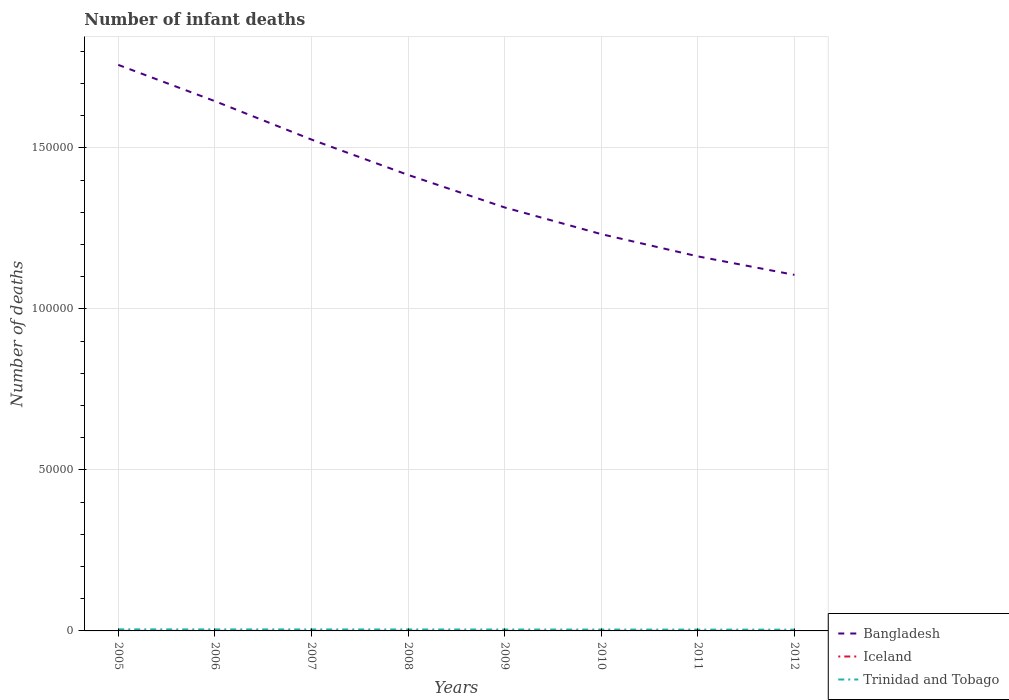Does the line corresponding to Iceland intersect with the line corresponding to Bangladesh?
Offer a very short reply. No. Across all years, what is the maximum number of infant deaths in Iceland?
Offer a terse response. 8. In which year was the number of infant deaths in Trinidad and Tobago maximum?
Ensure brevity in your answer.  2012. What is the total number of infant deaths in Iceland in the graph?
Your response must be concise. 1. What is the difference between the highest and the second highest number of infant deaths in Iceland?
Your response must be concise. 2. Is the number of infant deaths in Bangladesh strictly greater than the number of infant deaths in Iceland over the years?
Your response must be concise. No. How many lines are there?
Make the answer very short. 3. What is the difference between two consecutive major ticks on the Y-axis?
Give a very brief answer. 5.00e+04. Are the values on the major ticks of Y-axis written in scientific E-notation?
Keep it short and to the point. No. Does the graph contain any zero values?
Provide a short and direct response. No. Does the graph contain grids?
Ensure brevity in your answer.  Yes. How many legend labels are there?
Offer a very short reply. 3. What is the title of the graph?
Make the answer very short. Number of infant deaths. What is the label or title of the X-axis?
Your answer should be compact. Years. What is the label or title of the Y-axis?
Your response must be concise. Number of deaths. What is the Number of deaths of Bangladesh in 2005?
Your answer should be compact. 1.76e+05. What is the Number of deaths in Iceland in 2005?
Keep it short and to the point. 10. What is the Number of deaths in Trinidad and Tobago in 2005?
Offer a very short reply. 481. What is the Number of deaths in Bangladesh in 2006?
Your response must be concise. 1.65e+05. What is the Number of deaths in Trinidad and Tobago in 2006?
Offer a terse response. 475. What is the Number of deaths in Bangladesh in 2007?
Your answer should be compact. 1.53e+05. What is the Number of deaths in Trinidad and Tobago in 2007?
Provide a short and direct response. 466. What is the Number of deaths of Bangladesh in 2008?
Offer a very short reply. 1.42e+05. What is the Number of deaths in Iceland in 2008?
Provide a short and direct response. 10. What is the Number of deaths in Trinidad and Tobago in 2008?
Make the answer very short. 452. What is the Number of deaths of Bangladesh in 2009?
Make the answer very short. 1.32e+05. What is the Number of deaths of Trinidad and Tobago in 2009?
Your answer should be compact. 438. What is the Number of deaths in Bangladesh in 2010?
Offer a very short reply. 1.23e+05. What is the Number of deaths in Trinidad and Tobago in 2010?
Offer a terse response. 423. What is the Number of deaths in Bangladesh in 2011?
Your answer should be very brief. 1.16e+05. What is the Number of deaths in Iceland in 2011?
Your answer should be very brief. 9. What is the Number of deaths in Trinidad and Tobago in 2011?
Provide a succinct answer. 407. What is the Number of deaths of Bangladesh in 2012?
Offer a terse response. 1.11e+05. What is the Number of deaths in Trinidad and Tobago in 2012?
Provide a short and direct response. 389. Across all years, what is the maximum Number of deaths of Bangladesh?
Make the answer very short. 1.76e+05. Across all years, what is the maximum Number of deaths of Iceland?
Offer a very short reply. 10. Across all years, what is the maximum Number of deaths in Trinidad and Tobago?
Keep it short and to the point. 481. Across all years, what is the minimum Number of deaths of Bangladesh?
Make the answer very short. 1.11e+05. Across all years, what is the minimum Number of deaths of Iceland?
Give a very brief answer. 8. Across all years, what is the minimum Number of deaths of Trinidad and Tobago?
Keep it short and to the point. 389. What is the total Number of deaths of Bangladesh in the graph?
Offer a very short reply. 1.12e+06. What is the total Number of deaths in Trinidad and Tobago in the graph?
Provide a short and direct response. 3531. What is the difference between the Number of deaths in Bangladesh in 2005 and that in 2006?
Make the answer very short. 1.13e+04. What is the difference between the Number of deaths of Bangladesh in 2005 and that in 2007?
Offer a terse response. 2.32e+04. What is the difference between the Number of deaths of Bangladesh in 2005 and that in 2008?
Provide a succinct answer. 3.42e+04. What is the difference between the Number of deaths of Bangladesh in 2005 and that in 2009?
Provide a succinct answer. 4.43e+04. What is the difference between the Number of deaths in Iceland in 2005 and that in 2009?
Make the answer very short. 0. What is the difference between the Number of deaths of Trinidad and Tobago in 2005 and that in 2009?
Your answer should be compact. 43. What is the difference between the Number of deaths of Bangladesh in 2005 and that in 2010?
Offer a very short reply. 5.26e+04. What is the difference between the Number of deaths of Iceland in 2005 and that in 2010?
Make the answer very short. 0. What is the difference between the Number of deaths in Trinidad and Tobago in 2005 and that in 2010?
Ensure brevity in your answer.  58. What is the difference between the Number of deaths in Bangladesh in 2005 and that in 2011?
Ensure brevity in your answer.  5.95e+04. What is the difference between the Number of deaths in Iceland in 2005 and that in 2011?
Make the answer very short. 1. What is the difference between the Number of deaths of Trinidad and Tobago in 2005 and that in 2011?
Give a very brief answer. 74. What is the difference between the Number of deaths in Bangladesh in 2005 and that in 2012?
Ensure brevity in your answer.  6.52e+04. What is the difference between the Number of deaths in Trinidad and Tobago in 2005 and that in 2012?
Make the answer very short. 92. What is the difference between the Number of deaths of Bangladesh in 2006 and that in 2007?
Offer a terse response. 1.19e+04. What is the difference between the Number of deaths in Bangladesh in 2006 and that in 2008?
Give a very brief answer. 2.29e+04. What is the difference between the Number of deaths in Iceland in 2006 and that in 2008?
Offer a terse response. 0. What is the difference between the Number of deaths in Bangladesh in 2006 and that in 2009?
Provide a short and direct response. 3.30e+04. What is the difference between the Number of deaths in Trinidad and Tobago in 2006 and that in 2009?
Your answer should be compact. 37. What is the difference between the Number of deaths in Bangladesh in 2006 and that in 2010?
Provide a succinct answer. 4.13e+04. What is the difference between the Number of deaths of Bangladesh in 2006 and that in 2011?
Offer a terse response. 4.82e+04. What is the difference between the Number of deaths in Trinidad and Tobago in 2006 and that in 2011?
Your answer should be compact. 68. What is the difference between the Number of deaths in Bangladesh in 2006 and that in 2012?
Make the answer very short. 5.40e+04. What is the difference between the Number of deaths of Trinidad and Tobago in 2006 and that in 2012?
Provide a short and direct response. 86. What is the difference between the Number of deaths in Bangladesh in 2007 and that in 2008?
Your answer should be very brief. 1.10e+04. What is the difference between the Number of deaths of Iceland in 2007 and that in 2008?
Your response must be concise. 0. What is the difference between the Number of deaths of Trinidad and Tobago in 2007 and that in 2008?
Your response must be concise. 14. What is the difference between the Number of deaths in Bangladesh in 2007 and that in 2009?
Offer a very short reply. 2.11e+04. What is the difference between the Number of deaths in Bangladesh in 2007 and that in 2010?
Ensure brevity in your answer.  2.94e+04. What is the difference between the Number of deaths of Iceland in 2007 and that in 2010?
Give a very brief answer. 0. What is the difference between the Number of deaths in Trinidad and Tobago in 2007 and that in 2010?
Keep it short and to the point. 43. What is the difference between the Number of deaths in Bangladesh in 2007 and that in 2011?
Give a very brief answer. 3.63e+04. What is the difference between the Number of deaths in Bangladesh in 2007 and that in 2012?
Provide a succinct answer. 4.20e+04. What is the difference between the Number of deaths in Iceland in 2007 and that in 2012?
Your answer should be compact. 2. What is the difference between the Number of deaths in Bangladesh in 2008 and that in 2009?
Keep it short and to the point. 1.01e+04. What is the difference between the Number of deaths in Iceland in 2008 and that in 2009?
Provide a succinct answer. 0. What is the difference between the Number of deaths in Bangladesh in 2008 and that in 2010?
Offer a terse response. 1.84e+04. What is the difference between the Number of deaths of Bangladesh in 2008 and that in 2011?
Offer a terse response. 2.53e+04. What is the difference between the Number of deaths of Iceland in 2008 and that in 2011?
Offer a very short reply. 1. What is the difference between the Number of deaths in Bangladesh in 2008 and that in 2012?
Keep it short and to the point. 3.10e+04. What is the difference between the Number of deaths in Bangladesh in 2009 and that in 2010?
Offer a very short reply. 8288. What is the difference between the Number of deaths in Bangladesh in 2009 and that in 2011?
Offer a terse response. 1.52e+04. What is the difference between the Number of deaths of Bangladesh in 2009 and that in 2012?
Your answer should be very brief. 2.09e+04. What is the difference between the Number of deaths in Trinidad and Tobago in 2009 and that in 2012?
Keep it short and to the point. 49. What is the difference between the Number of deaths of Bangladesh in 2010 and that in 2011?
Make the answer very short. 6909. What is the difference between the Number of deaths in Iceland in 2010 and that in 2011?
Your answer should be compact. 1. What is the difference between the Number of deaths in Trinidad and Tobago in 2010 and that in 2011?
Provide a succinct answer. 16. What is the difference between the Number of deaths of Bangladesh in 2010 and that in 2012?
Your answer should be very brief. 1.27e+04. What is the difference between the Number of deaths of Bangladesh in 2011 and that in 2012?
Keep it short and to the point. 5744. What is the difference between the Number of deaths in Iceland in 2011 and that in 2012?
Your answer should be compact. 1. What is the difference between the Number of deaths of Bangladesh in 2005 and the Number of deaths of Iceland in 2006?
Your response must be concise. 1.76e+05. What is the difference between the Number of deaths in Bangladesh in 2005 and the Number of deaths in Trinidad and Tobago in 2006?
Make the answer very short. 1.75e+05. What is the difference between the Number of deaths of Iceland in 2005 and the Number of deaths of Trinidad and Tobago in 2006?
Make the answer very short. -465. What is the difference between the Number of deaths in Bangladesh in 2005 and the Number of deaths in Iceland in 2007?
Make the answer very short. 1.76e+05. What is the difference between the Number of deaths of Bangladesh in 2005 and the Number of deaths of Trinidad and Tobago in 2007?
Provide a short and direct response. 1.75e+05. What is the difference between the Number of deaths of Iceland in 2005 and the Number of deaths of Trinidad and Tobago in 2007?
Your response must be concise. -456. What is the difference between the Number of deaths of Bangladesh in 2005 and the Number of deaths of Iceland in 2008?
Your answer should be compact. 1.76e+05. What is the difference between the Number of deaths in Bangladesh in 2005 and the Number of deaths in Trinidad and Tobago in 2008?
Your answer should be very brief. 1.75e+05. What is the difference between the Number of deaths of Iceland in 2005 and the Number of deaths of Trinidad and Tobago in 2008?
Offer a very short reply. -442. What is the difference between the Number of deaths of Bangladesh in 2005 and the Number of deaths of Iceland in 2009?
Make the answer very short. 1.76e+05. What is the difference between the Number of deaths of Bangladesh in 2005 and the Number of deaths of Trinidad and Tobago in 2009?
Your answer should be compact. 1.75e+05. What is the difference between the Number of deaths in Iceland in 2005 and the Number of deaths in Trinidad and Tobago in 2009?
Your answer should be compact. -428. What is the difference between the Number of deaths in Bangladesh in 2005 and the Number of deaths in Iceland in 2010?
Make the answer very short. 1.76e+05. What is the difference between the Number of deaths of Bangladesh in 2005 and the Number of deaths of Trinidad and Tobago in 2010?
Give a very brief answer. 1.75e+05. What is the difference between the Number of deaths in Iceland in 2005 and the Number of deaths in Trinidad and Tobago in 2010?
Provide a short and direct response. -413. What is the difference between the Number of deaths of Bangladesh in 2005 and the Number of deaths of Iceland in 2011?
Your answer should be very brief. 1.76e+05. What is the difference between the Number of deaths in Bangladesh in 2005 and the Number of deaths in Trinidad and Tobago in 2011?
Make the answer very short. 1.75e+05. What is the difference between the Number of deaths of Iceland in 2005 and the Number of deaths of Trinidad and Tobago in 2011?
Keep it short and to the point. -397. What is the difference between the Number of deaths in Bangladesh in 2005 and the Number of deaths in Iceland in 2012?
Your answer should be compact. 1.76e+05. What is the difference between the Number of deaths of Bangladesh in 2005 and the Number of deaths of Trinidad and Tobago in 2012?
Offer a very short reply. 1.75e+05. What is the difference between the Number of deaths of Iceland in 2005 and the Number of deaths of Trinidad and Tobago in 2012?
Give a very brief answer. -379. What is the difference between the Number of deaths in Bangladesh in 2006 and the Number of deaths in Iceland in 2007?
Offer a terse response. 1.65e+05. What is the difference between the Number of deaths in Bangladesh in 2006 and the Number of deaths in Trinidad and Tobago in 2007?
Your answer should be compact. 1.64e+05. What is the difference between the Number of deaths in Iceland in 2006 and the Number of deaths in Trinidad and Tobago in 2007?
Keep it short and to the point. -456. What is the difference between the Number of deaths of Bangladesh in 2006 and the Number of deaths of Iceland in 2008?
Offer a very short reply. 1.65e+05. What is the difference between the Number of deaths in Bangladesh in 2006 and the Number of deaths in Trinidad and Tobago in 2008?
Your answer should be very brief. 1.64e+05. What is the difference between the Number of deaths in Iceland in 2006 and the Number of deaths in Trinidad and Tobago in 2008?
Provide a short and direct response. -442. What is the difference between the Number of deaths in Bangladesh in 2006 and the Number of deaths in Iceland in 2009?
Provide a short and direct response. 1.65e+05. What is the difference between the Number of deaths in Bangladesh in 2006 and the Number of deaths in Trinidad and Tobago in 2009?
Keep it short and to the point. 1.64e+05. What is the difference between the Number of deaths in Iceland in 2006 and the Number of deaths in Trinidad and Tobago in 2009?
Give a very brief answer. -428. What is the difference between the Number of deaths of Bangladesh in 2006 and the Number of deaths of Iceland in 2010?
Give a very brief answer. 1.65e+05. What is the difference between the Number of deaths in Bangladesh in 2006 and the Number of deaths in Trinidad and Tobago in 2010?
Your response must be concise. 1.64e+05. What is the difference between the Number of deaths in Iceland in 2006 and the Number of deaths in Trinidad and Tobago in 2010?
Offer a terse response. -413. What is the difference between the Number of deaths of Bangladesh in 2006 and the Number of deaths of Iceland in 2011?
Provide a short and direct response. 1.65e+05. What is the difference between the Number of deaths of Bangladesh in 2006 and the Number of deaths of Trinidad and Tobago in 2011?
Your response must be concise. 1.64e+05. What is the difference between the Number of deaths in Iceland in 2006 and the Number of deaths in Trinidad and Tobago in 2011?
Ensure brevity in your answer.  -397. What is the difference between the Number of deaths in Bangladesh in 2006 and the Number of deaths in Iceland in 2012?
Your response must be concise. 1.65e+05. What is the difference between the Number of deaths of Bangladesh in 2006 and the Number of deaths of Trinidad and Tobago in 2012?
Give a very brief answer. 1.64e+05. What is the difference between the Number of deaths in Iceland in 2006 and the Number of deaths in Trinidad and Tobago in 2012?
Give a very brief answer. -379. What is the difference between the Number of deaths in Bangladesh in 2007 and the Number of deaths in Iceland in 2008?
Ensure brevity in your answer.  1.53e+05. What is the difference between the Number of deaths in Bangladesh in 2007 and the Number of deaths in Trinidad and Tobago in 2008?
Give a very brief answer. 1.52e+05. What is the difference between the Number of deaths of Iceland in 2007 and the Number of deaths of Trinidad and Tobago in 2008?
Provide a short and direct response. -442. What is the difference between the Number of deaths in Bangladesh in 2007 and the Number of deaths in Iceland in 2009?
Give a very brief answer. 1.53e+05. What is the difference between the Number of deaths in Bangladesh in 2007 and the Number of deaths in Trinidad and Tobago in 2009?
Offer a very short reply. 1.52e+05. What is the difference between the Number of deaths in Iceland in 2007 and the Number of deaths in Trinidad and Tobago in 2009?
Offer a terse response. -428. What is the difference between the Number of deaths in Bangladesh in 2007 and the Number of deaths in Iceland in 2010?
Keep it short and to the point. 1.53e+05. What is the difference between the Number of deaths in Bangladesh in 2007 and the Number of deaths in Trinidad and Tobago in 2010?
Your answer should be compact. 1.52e+05. What is the difference between the Number of deaths of Iceland in 2007 and the Number of deaths of Trinidad and Tobago in 2010?
Offer a terse response. -413. What is the difference between the Number of deaths of Bangladesh in 2007 and the Number of deaths of Iceland in 2011?
Provide a succinct answer. 1.53e+05. What is the difference between the Number of deaths in Bangladesh in 2007 and the Number of deaths in Trinidad and Tobago in 2011?
Provide a short and direct response. 1.52e+05. What is the difference between the Number of deaths in Iceland in 2007 and the Number of deaths in Trinidad and Tobago in 2011?
Ensure brevity in your answer.  -397. What is the difference between the Number of deaths of Bangladesh in 2007 and the Number of deaths of Iceland in 2012?
Give a very brief answer. 1.53e+05. What is the difference between the Number of deaths of Bangladesh in 2007 and the Number of deaths of Trinidad and Tobago in 2012?
Offer a terse response. 1.52e+05. What is the difference between the Number of deaths of Iceland in 2007 and the Number of deaths of Trinidad and Tobago in 2012?
Provide a succinct answer. -379. What is the difference between the Number of deaths in Bangladesh in 2008 and the Number of deaths in Iceland in 2009?
Provide a succinct answer. 1.42e+05. What is the difference between the Number of deaths of Bangladesh in 2008 and the Number of deaths of Trinidad and Tobago in 2009?
Your answer should be compact. 1.41e+05. What is the difference between the Number of deaths of Iceland in 2008 and the Number of deaths of Trinidad and Tobago in 2009?
Provide a succinct answer. -428. What is the difference between the Number of deaths of Bangladesh in 2008 and the Number of deaths of Iceland in 2010?
Your response must be concise. 1.42e+05. What is the difference between the Number of deaths of Bangladesh in 2008 and the Number of deaths of Trinidad and Tobago in 2010?
Offer a very short reply. 1.41e+05. What is the difference between the Number of deaths in Iceland in 2008 and the Number of deaths in Trinidad and Tobago in 2010?
Provide a short and direct response. -413. What is the difference between the Number of deaths of Bangladesh in 2008 and the Number of deaths of Iceland in 2011?
Provide a succinct answer. 1.42e+05. What is the difference between the Number of deaths of Bangladesh in 2008 and the Number of deaths of Trinidad and Tobago in 2011?
Offer a terse response. 1.41e+05. What is the difference between the Number of deaths in Iceland in 2008 and the Number of deaths in Trinidad and Tobago in 2011?
Give a very brief answer. -397. What is the difference between the Number of deaths of Bangladesh in 2008 and the Number of deaths of Iceland in 2012?
Offer a terse response. 1.42e+05. What is the difference between the Number of deaths in Bangladesh in 2008 and the Number of deaths in Trinidad and Tobago in 2012?
Provide a succinct answer. 1.41e+05. What is the difference between the Number of deaths in Iceland in 2008 and the Number of deaths in Trinidad and Tobago in 2012?
Ensure brevity in your answer.  -379. What is the difference between the Number of deaths of Bangladesh in 2009 and the Number of deaths of Iceland in 2010?
Offer a very short reply. 1.32e+05. What is the difference between the Number of deaths in Bangladesh in 2009 and the Number of deaths in Trinidad and Tobago in 2010?
Keep it short and to the point. 1.31e+05. What is the difference between the Number of deaths of Iceland in 2009 and the Number of deaths of Trinidad and Tobago in 2010?
Keep it short and to the point. -413. What is the difference between the Number of deaths in Bangladesh in 2009 and the Number of deaths in Iceland in 2011?
Your answer should be compact. 1.32e+05. What is the difference between the Number of deaths of Bangladesh in 2009 and the Number of deaths of Trinidad and Tobago in 2011?
Ensure brevity in your answer.  1.31e+05. What is the difference between the Number of deaths of Iceland in 2009 and the Number of deaths of Trinidad and Tobago in 2011?
Offer a terse response. -397. What is the difference between the Number of deaths in Bangladesh in 2009 and the Number of deaths in Iceland in 2012?
Provide a short and direct response. 1.32e+05. What is the difference between the Number of deaths in Bangladesh in 2009 and the Number of deaths in Trinidad and Tobago in 2012?
Your answer should be very brief. 1.31e+05. What is the difference between the Number of deaths of Iceland in 2009 and the Number of deaths of Trinidad and Tobago in 2012?
Give a very brief answer. -379. What is the difference between the Number of deaths in Bangladesh in 2010 and the Number of deaths in Iceland in 2011?
Your answer should be compact. 1.23e+05. What is the difference between the Number of deaths in Bangladesh in 2010 and the Number of deaths in Trinidad and Tobago in 2011?
Keep it short and to the point. 1.23e+05. What is the difference between the Number of deaths of Iceland in 2010 and the Number of deaths of Trinidad and Tobago in 2011?
Your response must be concise. -397. What is the difference between the Number of deaths of Bangladesh in 2010 and the Number of deaths of Iceland in 2012?
Offer a very short reply. 1.23e+05. What is the difference between the Number of deaths of Bangladesh in 2010 and the Number of deaths of Trinidad and Tobago in 2012?
Provide a succinct answer. 1.23e+05. What is the difference between the Number of deaths in Iceland in 2010 and the Number of deaths in Trinidad and Tobago in 2012?
Offer a very short reply. -379. What is the difference between the Number of deaths in Bangladesh in 2011 and the Number of deaths in Iceland in 2012?
Offer a very short reply. 1.16e+05. What is the difference between the Number of deaths of Bangladesh in 2011 and the Number of deaths of Trinidad and Tobago in 2012?
Your response must be concise. 1.16e+05. What is the difference between the Number of deaths of Iceland in 2011 and the Number of deaths of Trinidad and Tobago in 2012?
Your response must be concise. -380. What is the average Number of deaths of Bangladesh per year?
Make the answer very short. 1.40e+05. What is the average Number of deaths in Iceland per year?
Your response must be concise. 9.62. What is the average Number of deaths in Trinidad and Tobago per year?
Provide a succinct answer. 441.38. In the year 2005, what is the difference between the Number of deaths in Bangladesh and Number of deaths in Iceland?
Offer a terse response. 1.76e+05. In the year 2005, what is the difference between the Number of deaths of Bangladesh and Number of deaths of Trinidad and Tobago?
Offer a terse response. 1.75e+05. In the year 2005, what is the difference between the Number of deaths in Iceland and Number of deaths in Trinidad and Tobago?
Your answer should be compact. -471. In the year 2006, what is the difference between the Number of deaths of Bangladesh and Number of deaths of Iceland?
Provide a short and direct response. 1.65e+05. In the year 2006, what is the difference between the Number of deaths in Bangladesh and Number of deaths in Trinidad and Tobago?
Ensure brevity in your answer.  1.64e+05. In the year 2006, what is the difference between the Number of deaths in Iceland and Number of deaths in Trinidad and Tobago?
Your answer should be compact. -465. In the year 2007, what is the difference between the Number of deaths in Bangladesh and Number of deaths in Iceland?
Provide a succinct answer. 1.53e+05. In the year 2007, what is the difference between the Number of deaths in Bangladesh and Number of deaths in Trinidad and Tobago?
Ensure brevity in your answer.  1.52e+05. In the year 2007, what is the difference between the Number of deaths of Iceland and Number of deaths of Trinidad and Tobago?
Keep it short and to the point. -456. In the year 2008, what is the difference between the Number of deaths in Bangladesh and Number of deaths in Iceland?
Offer a terse response. 1.42e+05. In the year 2008, what is the difference between the Number of deaths in Bangladesh and Number of deaths in Trinidad and Tobago?
Give a very brief answer. 1.41e+05. In the year 2008, what is the difference between the Number of deaths of Iceland and Number of deaths of Trinidad and Tobago?
Offer a very short reply. -442. In the year 2009, what is the difference between the Number of deaths in Bangladesh and Number of deaths in Iceland?
Make the answer very short. 1.32e+05. In the year 2009, what is the difference between the Number of deaths in Bangladesh and Number of deaths in Trinidad and Tobago?
Your answer should be compact. 1.31e+05. In the year 2009, what is the difference between the Number of deaths in Iceland and Number of deaths in Trinidad and Tobago?
Offer a terse response. -428. In the year 2010, what is the difference between the Number of deaths in Bangladesh and Number of deaths in Iceland?
Provide a short and direct response. 1.23e+05. In the year 2010, what is the difference between the Number of deaths of Bangladesh and Number of deaths of Trinidad and Tobago?
Keep it short and to the point. 1.23e+05. In the year 2010, what is the difference between the Number of deaths of Iceland and Number of deaths of Trinidad and Tobago?
Keep it short and to the point. -413. In the year 2011, what is the difference between the Number of deaths in Bangladesh and Number of deaths in Iceland?
Give a very brief answer. 1.16e+05. In the year 2011, what is the difference between the Number of deaths of Bangladesh and Number of deaths of Trinidad and Tobago?
Your response must be concise. 1.16e+05. In the year 2011, what is the difference between the Number of deaths of Iceland and Number of deaths of Trinidad and Tobago?
Keep it short and to the point. -398. In the year 2012, what is the difference between the Number of deaths in Bangladesh and Number of deaths in Iceland?
Provide a succinct answer. 1.11e+05. In the year 2012, what is the difference between the Number of deaths of Bangladesh and Number of deaths of Trinidad and Tobago?
Ensure brevity in your answer.  1.10e+05. In the year 2012, what is the difference between the Number of deaths in Iceland and Number of deaths in Trinidad and Tobago?
Your answer should be very brief. -381. What is the ratio of the Number of deaths of Bangladesh in 2005 to that in 2006?
Keep it short and to the point. 1.07. What is the ratio of the Number of deaths in Iceland in 2005 to that in 2006?
Your answer should be compact. 1. What is the ratio of the Number of deaths in Trinidad and Tobago in 2005 to that in 2006?
Offer a very short reply. 1.01. What is the ratio of the Number of deaths of Bangladesh in 2005 to that in 2007?
Your answer should be very brief. 1.15. What is the ratio of the Number of deaths of Trinidad and Tobago in 2005 to that in 2007?
Your response must be concise. 1.03. What is the ratio of the Number of deaths in Bangladesh in 2005 to that in 2008?
Ensure brevity in your answer.  1.24. What is the ratio of the Number of deaths of Trinidad and Tobago in 2005 to that in 2008?
Offer a very short reply. 1.06. What is the ratio of the Number of deaths of Bangladesh in 2005 to that in 2009?
Offer a terse response. 1.34. What is the ratio of the Number of deaths in Iceland in 2005 to that in 2009?
Keep it short and to the point. 1. What is the ratio of the Number of deaths in Trinidad and Tobago in 2005 to that in 2009?
Your answer should be compact. 1.1. What is the ratio of the Number of deaths in Bangladesh in 2005 to that in 2010?
Ensure brevity in your answer.  1.43. What is the ratio of the Number of deaths of Iceland in 2005 to that in 2010?
Ensure brevity in your answer.  1. What is the ratio of the Number of deaths of Trinidad and Tobago in 2005 to that in 2010?
Your answer should be very brief. 1.14. What is the ratio of the Number of deaths in Bangladesh in 2005 to that in 2011?
Keep it short and to the point. 1.51. What is the ratio of the Number of deaths of Trinidad and Tobago in 2005 to that in 2011?
Your response must be concise. 1.18. What is the ratio of the Number of deaths in Bangladesh in 2005 to that in 2012?
Make the answer very short. 1.59. What is the ratio of the Number of deaths of Iceland in 2005 to that in 2012?
Provide a short and direct response. 1.25. What is the ratio of the Number of deaths in Trinidad and Tobago in 2005 to that in 2012?
Provide a short and direct response. 1.24. What is the ratio of the Number of deaths of Bangladesh in 2006 to that in 2007?
Provide a short and direct response. 1.08. What is the ratio of the Number of deaths in Trinidad and Tobago in 2006 to that in 2007?
Your response must be concise. 1.02. What is the ratio of the Number of deaths of Bangladesh in 2006 to that in 2008?
Ensure brevity in your answer.  1.16. What is the ratio of the Number of deaths of Iceland in 2006 to that in 2008?
Give a very brief answer. 1. What is the ratio of the Number of deaths in Trinidad and Tobago in 2006 to that in 2008?
Provide a short and direct response. 1.05. What is the ratio of the Number of deaths in Bangladesh in 2006 to that in 2009?
Provide a short and direct response. 1.25. What is the ratio of the Number of deaths of Trinidad and Tobago in 2006 to that in 2009?
Ensure brevity in your answer.  1.08. What is the ratio of the Number of deaths of Bangladesh in 2006 to that in 2010?
Offer a very short reply. 1.34. What is the ratio of the Number of deaths in Trinidad and Tobago in 2006 to that in 2010?
Your answer should be very brief. 1.12. What is the ratio of the Number of deaths in Bangladesh in 2006 to that in 2011?
Your answer should be compact. 1.41. What is the ratio of the Number of deaths of Iceland in 2006 to that in 2011?
Your answer should be very brief. 1.11. What is the ratio of the Number of deaths in Trinidad and Tobago in 2006 to that in 2011?
Provide a succinct answer. 1.17. What is the ratio of the Number of deaths of Bangladesh in 2006 to that in 2012?
Ensure brevity in your answer.  1.49. What is the ratio of the Number of deaths of Iceland in 2006 to that in 2012?
Keep it short and to the point. 1.25. What is the ratio of the Number of deaths in Trinidad and Tobago in 2006 to that in 2012?
Ensure brevity in your answer.  1.22. What is the ratio of the Number of deaths of Bangladesh in 2007 to that in 2008?
Keep it short and to the point. 1.08. What is the ratio of the Number of deaths in Trinidad and Tobago in 2007 to that in 2008?
Provide a short and direct response. 1.03. What is the ratio of the Number of deaths of Bangladesh in 2007 to that in 2009?
Ensure brevity in your answer.  1.16. What is the ratio of the Number of deaths in Trinidad and Tobago in 2007 to that in 2009?
Provide a short and direct response. 1.06. What is the ratio of the Number of deaths of Bangladesh in 2007 to that in 2010?
Provide a short and direct response. 1.24. What is the ratio of the Number of deaths of Trinidad and Tobago in 2007 to that in 2010?
Provide a short and direct response. 1.1. What is the ratio of the Number of deaths in Bangladesh in 2007 to that in 2011?
Provide a short and direct response. 1.31. What is the ratio of the Number of deaths of Iceland in 2007 to that in 2011?
Offer a terse response. 1.11. What is the ratio of the Number of deaths in Trinidad and Tobago in 2007 to that in 2011?
Keep it short and to the point. 1.15. What is the ratio of the Number of deaths of Bangladesh in 2007 to that in 2012?
Your answer should be compact. 1.38. What is the ratio of the Number of deaths of Iceland in 2007 to that in 2012?
Offer a very short reply. 1.25. What is the ratio of the Number of deaths of Trinidad and Tobago in 2007 to that in 2012?
Your answer should be compact. 1.2. What is the ratio of the Number of deaths in Bangladesh in 2008 to that in 2009?
Keep it short and to the point. 1.08. What is the ratio of the Number of deaths of Iceland in 2008 to that in 2009?
Ensure brevity in your answer.  1. What is the ratio of the Number of deaths in Trinidad and Tobago in 2008 to that in 2009?
Keep it short and to the point. 1.03. What is the ratio of the Number of deaths in Bangladesh in 2008 to that in 2010?
Ensure brevity in your answer.  1.15. What is the ratio of the Number of deaths of Iceland in 2008 to that in 2010?
Ensure brevity in your answer.  1. What is the ratio of the Number of deaths of Trinidad and Tobago in 2008 to that in 2010?
Give a very brief answer. 1.07. What is the ratio of the Number of deaths in Bangladesh in 2008 to that in 2011?
Your response must be concise. 1.22. What is the ratio of the Number of deaths of Iceland in 2008 to that in 2011?
Offer a terse response. 1.11. What is the ratio of the Number of deaths of Trinidad and Tobago in 2008 to that in 2011?
Keep it short and to the point. 1.11. What is the ratio of the Number of deaths of Bangladesh in 2008 to that in 2012?
Offer a very short reply. 1.28. What is the ratio of the Number of deaths in Iceland in 2008 to that in 2012?
Offer a terse response. 1.25. What is the ratio of the Number of deaths in Trinidad and Tobago in 2008 to that in 2012?
Your answer should be compact. 1.16. What is the ratio of the Number of deaths in Bangladesh in 2009 to that in 2010?
Your answer should be very brief. 1.07. What is the ratio of the Number of deaths of Iceland in 2009 to that in 2010?
Make the answer very short. 1. What is the ratio of the Number of deaths of Trinidad and Tobago in 2009 to that in 2010?
Your answer should be very brief. 1.04. What is the ratio of the Number of deaths in Bangladesh in 2009 to that in 2011?
Your response must be concise. 1.13. What is the ratio of the Number of deaths of Trinidad and Tobago in 2009 to that in 2011?
Provide a succinct answer. 1.08. What is the ratio of the Number of deaths of Bangladesh in 2009 to that in 2012?
Give a very brief answer. 1.19. What is the ratio of the Number of deaths in Iceland in 2009 to that in 2012?
Offer a very short reply. 1.25. What is the ratio of the Number of deaths of Trinidad and Tobago in 2009 to that in 2012?
Provide a short and direct response. 1.13. What is the ratio of the Number of deaths of Bangladesh in 2010 to that in 2011?
Your answer should be compact. 1.06. What is the ratio of the Number of deaths of Iceland in 2010 to that in 2011?
Keep it short and to the point. 1.11. What is the ratio of the Number of deaths of Trinidad and Tobago in 2010 to that in 2011?
Offer a terse response. 1.04. What is the ratio of the Number of deaths in Bangladesh in 2010 to that in 2012?
Provide a short and direct response. 1.11. What is the ratio of the Number of deaths of Iceland in 2010 to that in 2012?
Your response must be concise. 1.25. What is the ratio of the Number of deaths of Trinidad and Tobago in 2010 to that in 2012?
Your response must be concise. 1.09. What is the ratio of the Number of deaths of Bangladesh in 2011 to that in 2012?
Keep it short and to the point. 1.05. What is the ratio of the Number of deaths of Trinidad and Tobago in 2011 to that in 2012?
Ensure brevity in your answer.  1.05. What is the difference between the highest and the second highest Number of deaths in Bangladesh?
Offer a terse response. 1.13e+04. What is the difference between the highest and the second highest Number of deaths in Iceland?
Provide a short and direct response. 0. What is the difference between the highest and the lowest Number of deaths of Bangladesh?
Keep it short and to the point. 6.52e+04. What is the difference between the highest and the lowest Number of deaths of Iceland?
Provide a short and direct response. 2. What is the difference between the highest and the lowest Number of deaths of Trinidad and Tobago?
Offer a very short reply. 92. 